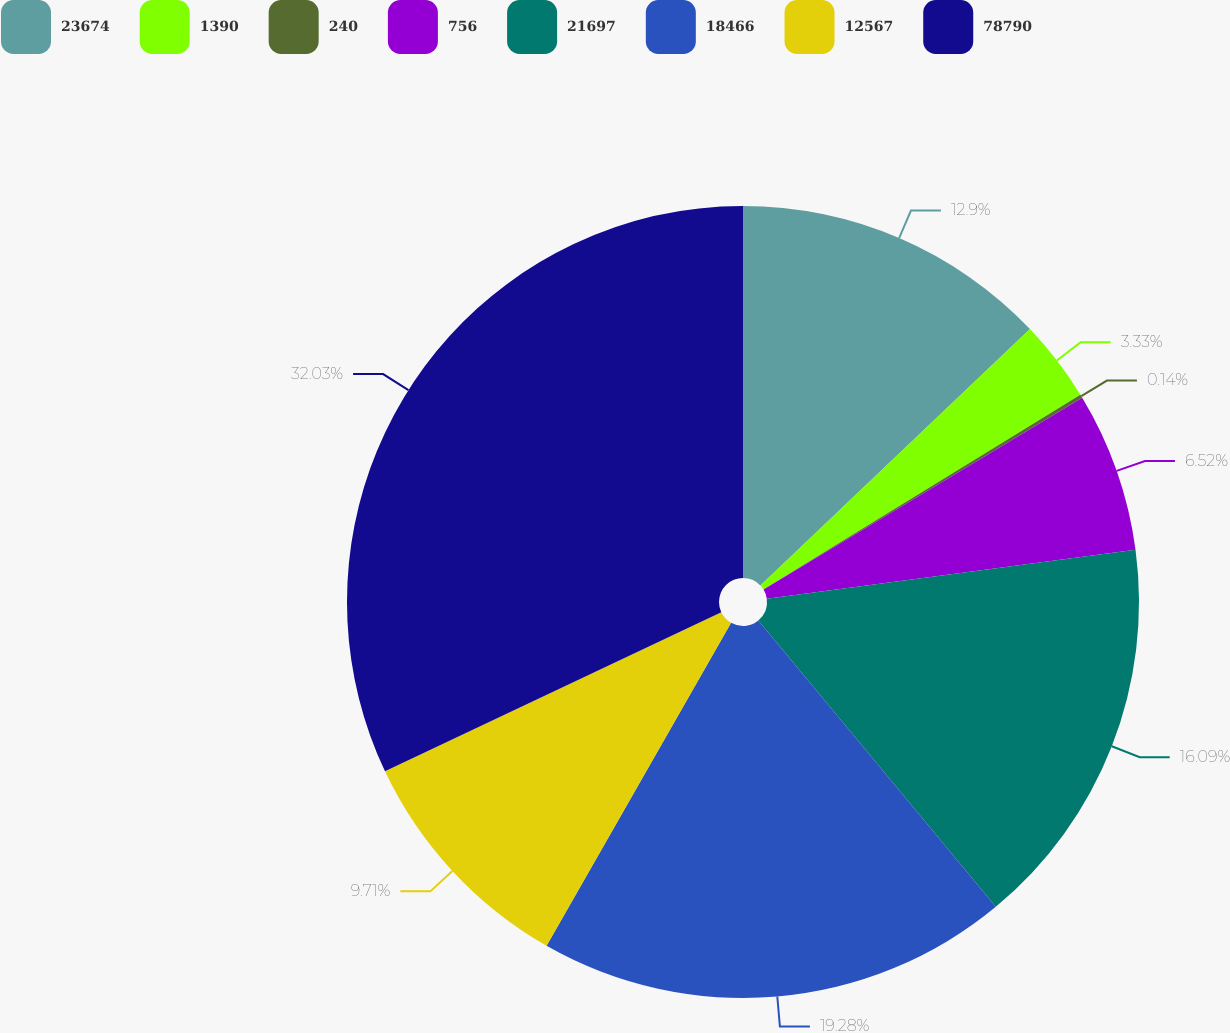Convert chart. <chart><loc_0><loc_0><loc_500><loc_500><pie_chart><fcel>23674<fcel>1390<fcel>240<fcel>756<fcel>21697<fcel>18466<fcel>12567<fcel>78790<nl><fcel>12.9%<fcel>3.33%<fcel>0.14%<fcel>6.52%<fcel>16.09%<fcel>19.28%<fcel>9.71%<fcel>32.03%<nl></chart> 